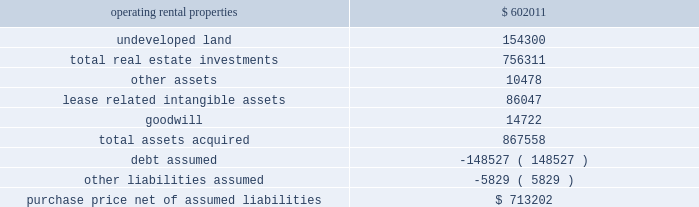As approximately 161 acres of undeveloped land and a 12-acre container storage facility in houston .
The total price was $ 89.7 million and was financed in part through assumption of secured debt that had a fair value of $ 34.3 million .
Of the total purchase price , $ 64.1 million was allocated to in-service real estate assets , $ 20.0 million was allocated to undeveloped land and the container storage facility , $ 5.4 million was allocated to lease related intangible assets , and the remaining amount was allocated to acquired working capital related assets and liabilities .
The results of operations for the acquired properties since the date of acquisition have been included in continuing rental operations in our consolidated financial statements .
In february 2007 , we completed the acquisition of bremner healthcare real estate ( 201cbremner 201d ) , a national health care development and management firm .
The primary reason for the acquisition was to expand our development capabilities within the health care real estate market .
The initial consideration paid to the sellers totaled $ 47.1 million , and the sellers may be eligible for further contingent payments over a three-year period following the acquisition .
Approximately $ 39.0 million of the total purchase price was allocated to goodwill , which is attributable to the value of bremner 2019s overall development capabilities and its in-place workforce .
The results of operations for bremner since the date of acquisition have been included in continuing operations in our consolidated financial statements .
In february 2006 , we acquired the majority of a washington , d.c .
Metropolitan area portfolio of suburban office and light industrial properties ( the 201cmark winkler portfolio 201d ) .
The assets acquired for a purchase price of approximately $ 867.6 million were comprised of 32 in-service properties with approximately 2.9 million square feet for rental , 166 acres of undeveloped land , as well as certain related assets of the mark winkler company , a real estate management company .
The acquisition was financed primarily through assumed mortgage loans and new borrowings .
The assets acquired and liabilities assumed were recorded at their estimated fair value at the date of acquisition , as summarized below ( in thousands ) : .
Purchase price , net of assumed liabilities $ 713202 in december 2006 , we contributed 23 of these in-service properties acquired from the mark winkler portfolio with a basis of $ 381.6 million representing real estate investments and acquired lease related intangible assets to two new unconsolidated subsidiaries .
Of the remaining nine in-service properties , eight were contributed to these two unconsolidated subsidiaries in 2007 and one remains in continuing operations as of december 31 , 2008 .
The eight properties contributed in 2007 had a basis of $ 298.4 million representing real estate investments and acquired lease related intangible assets , and debt secured by these properties of $ 146.4 million was also assumed by the unconsolidated subsidiaries .
In the third quarter of 2006 , we finalized the purchase of a portfolio of industrial real estate properties in savannah , georgia .
We completed a majority of the purchase in january 2006 .
The assets acquired for a purchase price of approximately $ 196.2 million were comprised of 18 buildings with approximately 5.1 million square feet for rental as well as over 60 acres of undeveloped land .
The acquisition was financed in part through assumed mortgage loans .
The results of operations for the acquired properties since the date of acquisition have been included in continuing rental operations in our consolidated financial statements. .
What are the total real estate investments as a percentage of the total assets acquired? 
Computations: ((756311 / 867558) * 100)
Answer: 87.177. 